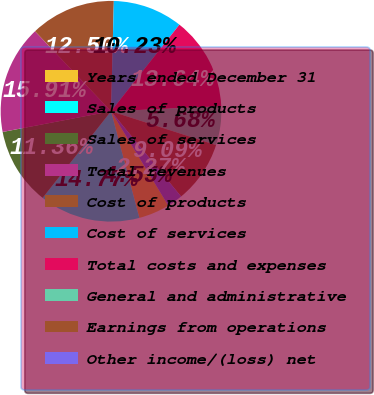<chart> <loc_0><loc_0><loc_500><loc_500><pie_chart><fcel>Years ended December 31<fcel>Sales of products<fcel>Sales of services<fcel>Total revenues<fcel>Cost of products<fcel>Cost of services<fcel>Total costs and expenses<fcel>General and administrative<fcel>Earnings from operations<fcel>Other income/(loss) net<nl><fcel>4.55%<fcel>14.77%<fcel>11.36%<fcel>15.91%<fcel>12.5%<fcel>10.23%<fcel>13.64%<fcel>5.68%<fcel>9.09%<fcel>2.27%<nl></chart> 